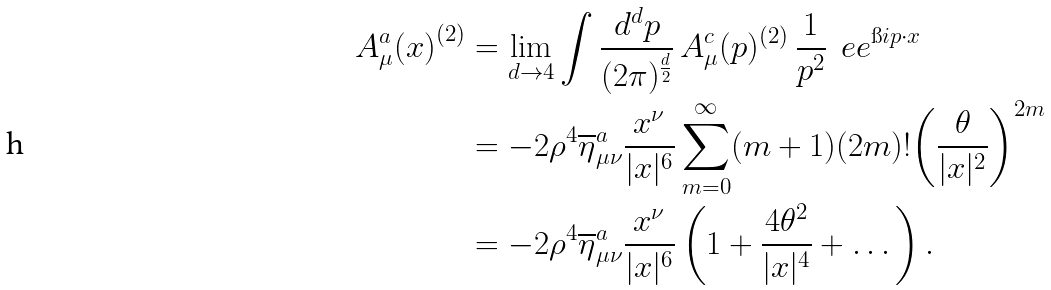Convert formula to latex. <formula><loc_0><loc_0><loc_500><loc_500>{ A ^ { a } _ { \mu } ( x ) } ^ { ( 2 ) } & = \lim _ { d \to 4 } \int \frac { d ^ { d } p } { ( 2 \pi ) ^ { \frac { d } { 2 } } } \, A ^ { c } _ { \mu } ( p ) ^ { ( 2 ) } \, \frac { 1 } { p ^ { 2 } } \, \ e e ^ { \i i p \cdot x } \\ & = - 2 \rho ^ { 4 } \overline { \eta } ^ { a } _ { \mu \nu } \frac { x ^ { \nu } } { | x | ^ { 6 } } \sum ^ { \infty } _ { m = 0 } ( m + 1 ) ( 2 m ) ! { \left ( \frac { \theta } { | x | ^ { 2 } } \right ) } ^ { 2 m } \\ & = - 2 \rho ^ { 4 } \overline { \eta } ^ { a } _ { \mu \nu } \frac { x ^ { \nu } } { | x | ^ { 6 } } \left ( 1 + \frac { 4 \theta ^ { 2 } } { | x | ^ { 4 } } + \dots \right ) .</formula> 